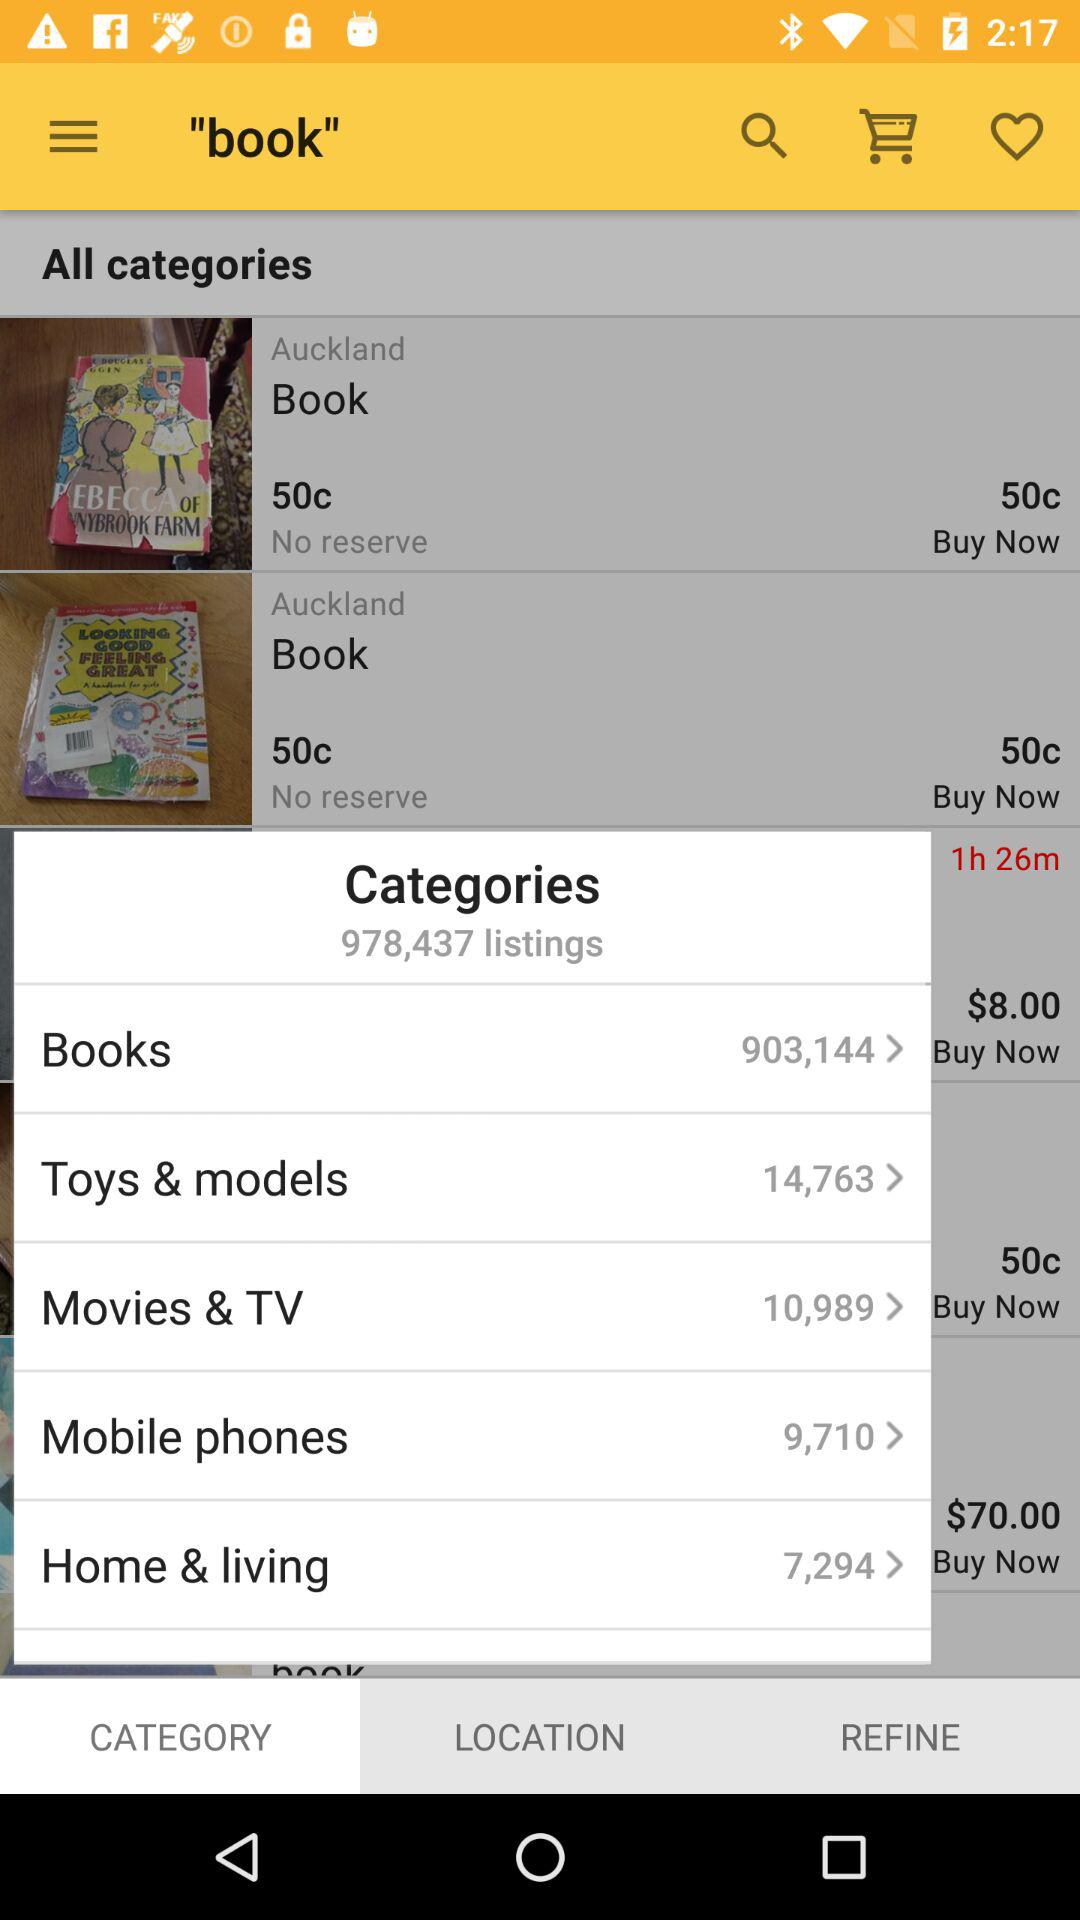How many results are there for the category Toys & models?
Answer the question using a single word or phrase. 14,763 